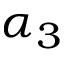Convert formula to latex. <formula><loc_0><loc_0><loc_500><loc_500>\alpha _ { 3 }</formula> 